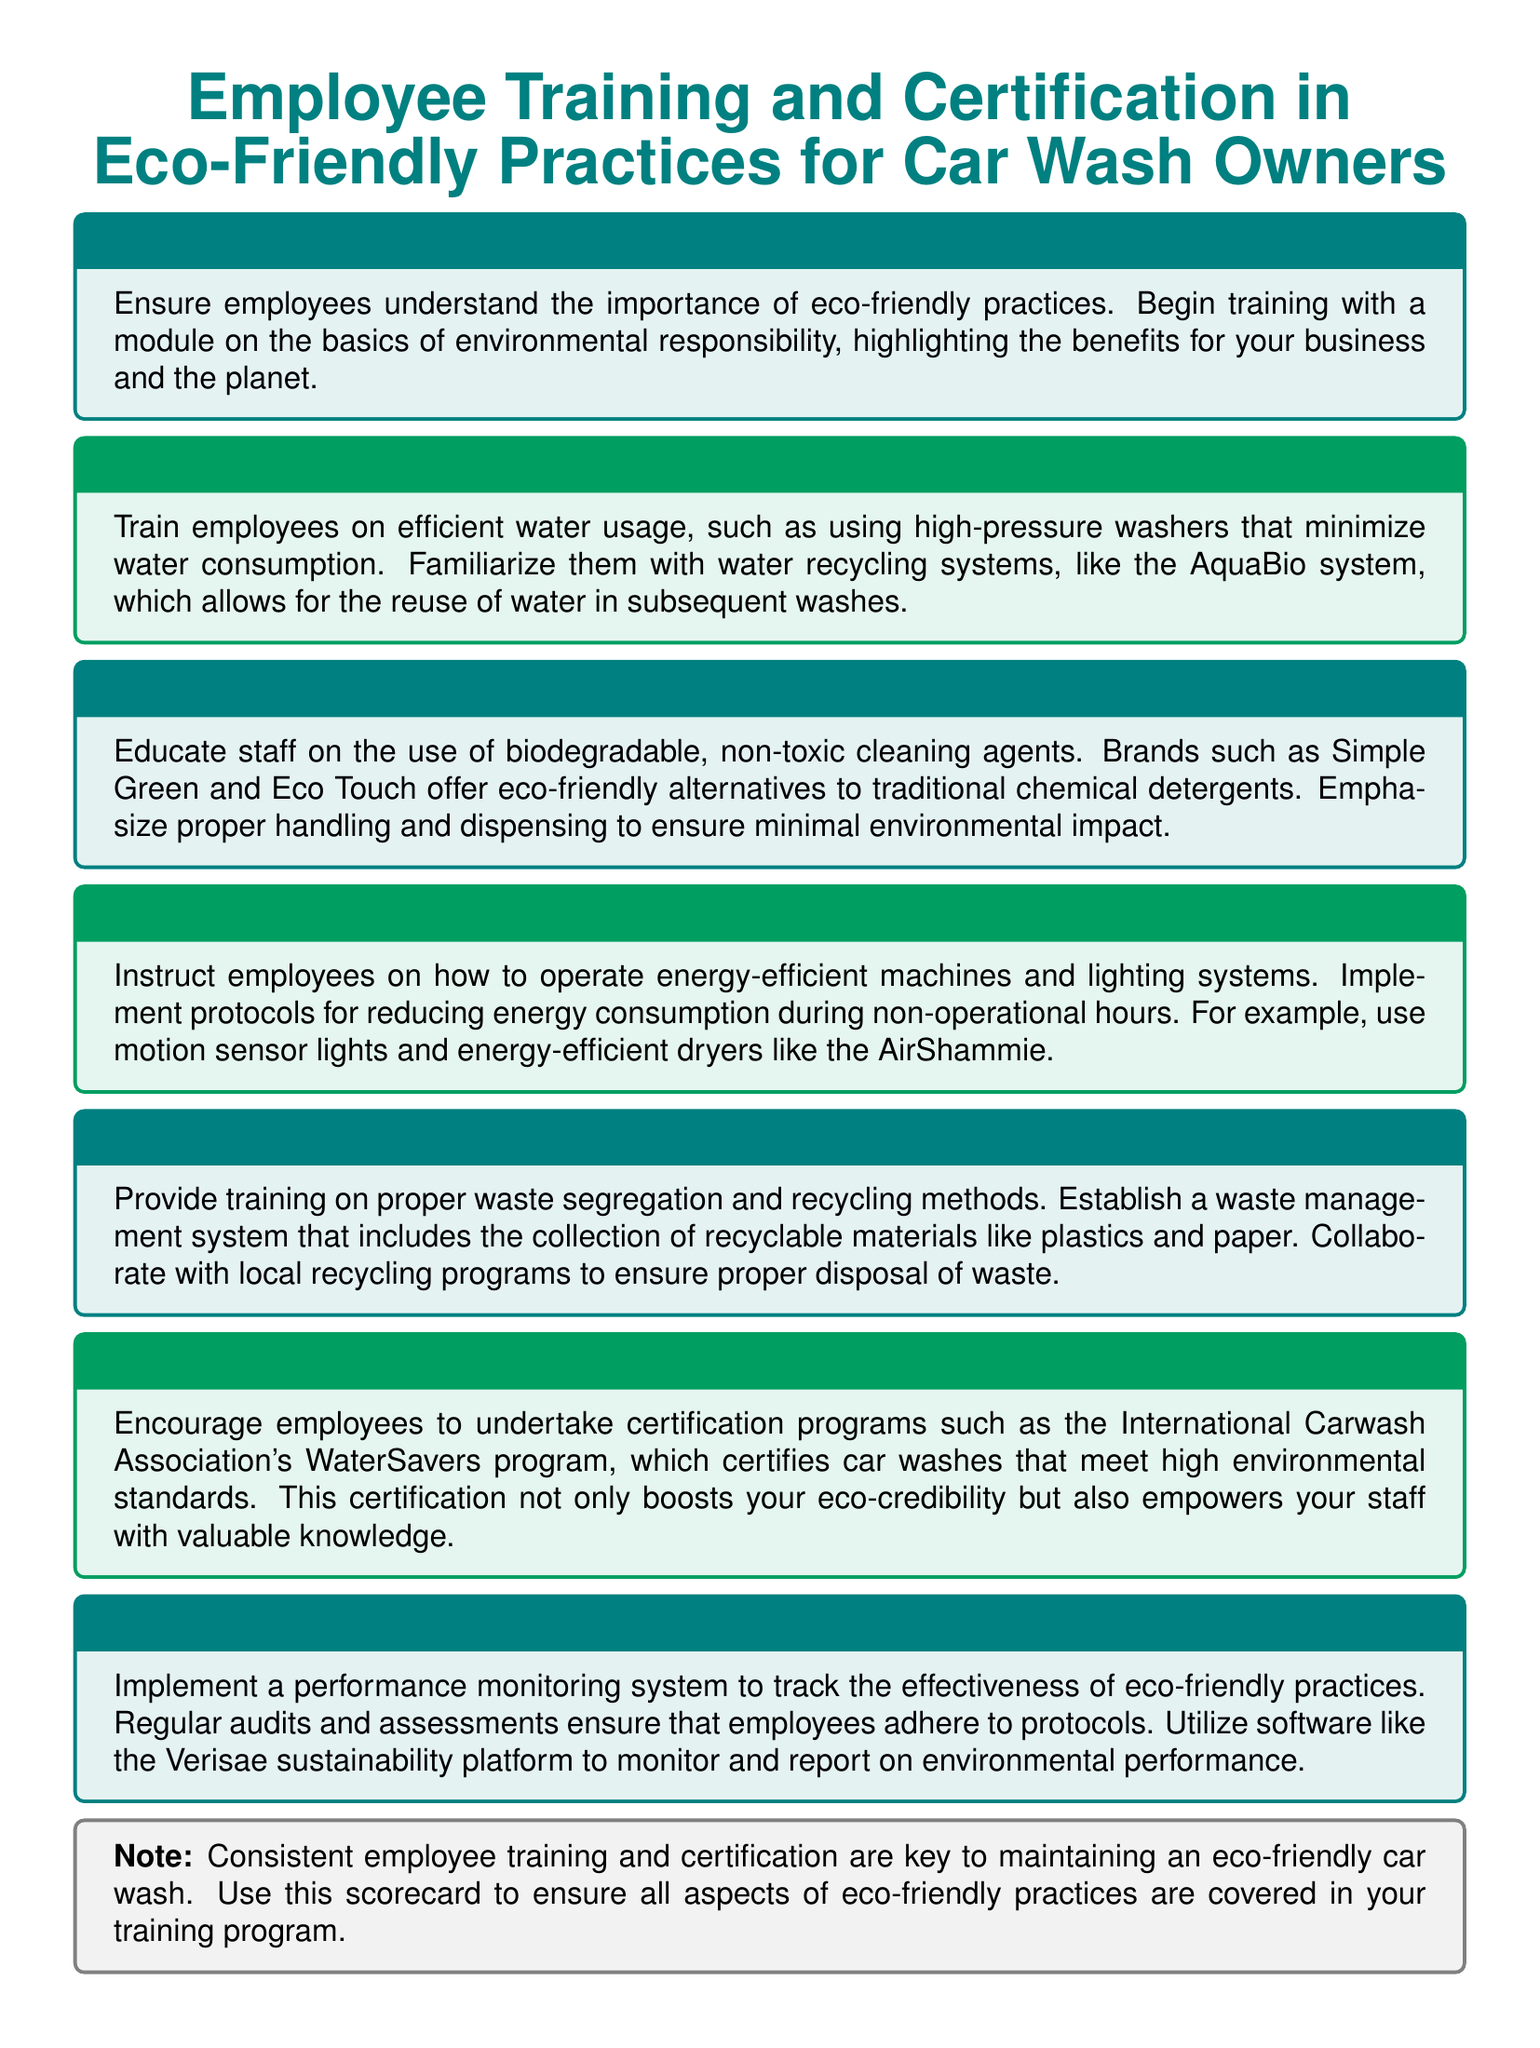What is the purpose of employee training? The purpose of employee training is to ensure employees understand the importance of eco-friendly practices.
Answer: Importance of eco-friendly practices What is the AquaBio system? The AquaBio system allows for the reuse of water in subsequent washes.
Answer: Reuse of water Which cleaning products are recommended? Brands such as Simple Green and Eco Touch are recommended for eco-friendly cleaning alternatives.
Answer: Simple Green and Eco Touch What does the WaterSavers program certify? The WaterSavers program certifies car washes that meet high environmental standards.
Answer: High environmental standards What type of lighting systems should be used? Energy-efficient lighting systems and motion sensor lights should be used to reduce energy consumption.
Answer: Energy-efficient and motion sensor lights How often should performance monitoring occur? Regular audits and assessments ensure that employees adhere to protocols.
Answer: Regularly What should be established for waste management? Establish a waste management system that includes the collection of recyclable materials.
Answer: Waste management system What is a key to maintaining an eco-friendly car wash? Consistent employee training and certification are key to maintaining an eco-friendly car wash.
Answer: Consistent training and certification 